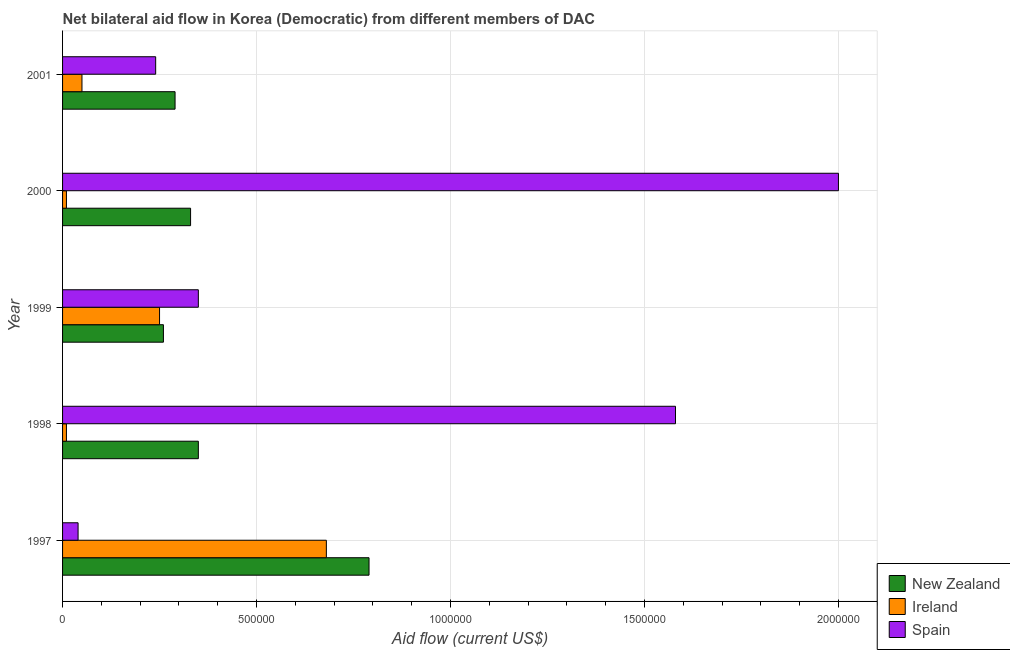How many different coloured bars are there?
Your answer should be very brief. 3. How many groups of bars are there?
Your answer should be compact. 5. Are the number of bars per tick equal to the number of legend labels?
Ensure brevity in your answer.  Yes. How many bars are there on the 1st tick from the top?
Your response must be concise. 3. What is the label of the 2nd group of bars from the top?
Offer a terse response. 2000. What is the amount of aid provided by ireland in 2001?
Keep it short and to the point. 5.00e+04. Across all years, what is the maximum amount of aid provided by spain?
Provide a succinct answer. 2.00e+06. Across all years, what is the minimum amount of aid provided by ireland?
Offer a very short reply. 10000. What is the total amount of aid provided by spain in the graph?
Your answer should be very brief. 4.21e+06. What is the difference between the amount of aid provided by spain in 1997 and that in 2001?
Make the answer very short. -2.00e+05. What is the difference between the amount of aid provided by ireland in 2001 and the amount of aid provided by spain in 1997?
Your answer should be very brief. 10000. What is the average amount of aid provided by spain per year?
Offer a terse response. 8.42e+05. In the year 2000, what is the difference between the amount of aid provided by new zealand and amount of aid provided by ireland?
Provide a short and direct response. 3.20e+05. What is the ratio of the amount of aid provided by new zealand in 1998 to that in 2001?
Make the answer very short. 1.21. What is the difference between the highest and the second highest amount of aid provided by ireland?
Give a very brief answer. 4.30e+05. What is the difference between the highest and the lowest amount of aid provided by spain?
Your response must be concise. 1.96e+06. What does the 2nd bar from the top in 2000 represents?
Provide a short and direct response. Ireland. What does the 1st bar from the bottom in 2000 represents?
Your answer should be very brief. New Zealand. How many bars are there?
Provide a succinct answer. 15. Are all the bars in the graph horizontal?
Offer a terse response. Yes. How many years are there in the graph?
Give a very brief answer. 5. Are the values on the major ticks of X-axis written in scientific E-notation?
Your response must be concise. No. Does the graph contain any zero values?
Your answer should be very brief. No. What is the title of the graph?
Ensure brevity in your answer.  Net bilateral aid flow in Korea (Democratic) from different members of DAC. Does "Ages 20-60" appear as one of the legend labels in the graph?
Give a very brief answer. No. What is the label or title of the Y-axis?
Ensure brevity in your answer.  Year. What is the Aid flow (current US$) of New Zealand in 1997?
Your response must be concise. 7.90e+05. What is the Aid flow (current US$) in Ireland in 1997?
Your answer should be compact. 6.80e+05. What is the Aid flow (current US$) of Spain in 1997?
Ensure brevity in your answer.  4.00e+04. What is the Aid flow (current US$) in New Zealand in 1998?
Keep it short and to the point. 3.50e+05. What is the Aid flow (current US$) in Spain in 1998?
Your response must be concise. 1.58e+06. What is the Aid flow (current US$) in Ireland in 1999?
Keep it short and to the point. 2.50e+05. What is the Aid flow (current US$) in Spain in 1999?
Your answer should be compact. 3.50e+05. What is the Aid flow (current US$) of New Zealand in 2000?
Give a very brief answer. 3.30e+05. What is the Aid flow (current US$) of Spain in 2000?
Your answer should be compact. 2.00e+06. What is the Aid flow (current US$) of New Zealand in 2001?
Provide a succinct answer. 2.90e+05. What is the Aid flow (current US$) of Spain in 2001?
Your answer should be compact. 2.40e+05. Across all years, what is the maximum Aid flow (current US$) of New Zealand?
Your response must be concise. 7.90e+05. Across all years, what is the maximum Aid flow (current US$) in Ireland?
Offer a terse response. 6.80e+05. Across all years, what is the maximum Aid flow (current US$) in Spain?
Provide a short and direct response. 2.00e+06. What is the total Aid flow (current US$) in New Zealand in the graph?
Provide a short and direct response. 2.02e+06. What is the total Aid flow (current US$) in Ireland in the graph?
Your answer should be compact. 1.00e+06. What is the total Aid flow (current US$) of Spain in the graph?
Your response must be concise. 4.21e+06. What is the difference between the Aid flow (current US$) in New Zealand in 1997 and that in 1998?
Your answer should be compact. 4.40e+05. What is the difference between the Aid flow (current US$) of Ireland in 1997 and that in 1998?
Keep it short and to the point. 6.70e+05. What is the difference between the Aid flow (current US$) in Spain in 1997 and that in 1998?
Offer a very short reply. -1.54e+06. What is the difference between the Aid flow (current US$) in New Zealand in 1997 and that in 1999?
Provide a short and direct response. 5.30e+05. What is the difference between the Aid flow (current US$) in Ireland in 1997 and that in 1999?
Keep it short and to the point. 4.30e+05. What is the difference between the Aid flow (current US$) in Spain in 1997 and that in 1999?
Your response must be concise. -3.10e+05. What is the difference between the Aid flow (current US$) of Ireland in 1997 and that in 2000?
Provide a short and direct response. 6.70e+05. What is the difference between the Aid flow (current US$) in Spain in 1997 and that in 2000?
Your response must be concise. -1.96e+06. What is the difference between the Aid flow (current US$) in New Zealand in 1997 and that in 2001?
Offer a very short reply. 5.00e+05. What is the difference between the Aid flow (current US$) of Ireland in 1997 and that in 2001?
Your answer should be very brief. 6.30e+05. What is the difference between the Aid flow (current US$) in Spain in 1997 and that in 2001?
Your answer should be very brief. -2.00e+05. What is the difference between the Aid flow (current US$) of New Zealand in 1998 and that in 1999?
Your answer should be compact. 9.00e+04. What is the difference between the Aid flow (current US$) in Ireland in 1998 and that in 1999?
Offer a terse response. -2.40e+05. What is the difference between the Aid flow (current US$) in Spain in 1998 and that in 1999?
Your answer should be very brief. 1.23e+06. What is the difference between the Aid flow (current US$) in New Zealand in 1998 and that in 2000?
Your response must be concise. 2.00e+04. What is the difference between the Aid flow (current US$) of Ireland in 1998 and that in 2000?
Your answer should be compact. 0. What is the difference between the Aid flow (current US$) in Spain in 1998 and that in 2000?
Ensure brevity in your answer.  -4.20e+05. What is the difference between the Aid flow (current US$) of Ireland in 1998 and that in 2001?
Your answer should be very brief. -4.00e+04. What is the difference between the Aid flow (current US$) of Spain in 1998 and that in 2001?
Offer a very short reply. 1.34e+06. What is the difference between the Aid flow (current US$) of New Zealand in 1999 and that in 2000?
Keep it short and to the point. -7.00e+04. What is the difference between the Aid flow (current US$) in Ireland in 1999 and that in 2000?
Provide a short and direct response. 2.40e+05. What is the difference between the Aid flow (current US$) in Spain in 1999 and that in 2000?
Your answer should be very brief. -1.65e+06. What is the difference between the Aid flow (current US$) of New Zealand in 1999 and that in 2001?
Give a very brief answer. -3.00e+04. What is the difference between the Aid flow (current US$) in Ireland in 1999 and that in 2001?
Ensure brevity in your answer.  2.00e+05. What is the difference between the Aid flow (current US$) in Spain in 2000 and that in 2001?
Provide a succinct answer. 1.76e+06. What is the difference between the Aid flow (current US$) of New Zealand in 1997 and the Aid flow (current US$) of Ireland in 1998?
Make the answer very short. 7.80e+05. What is the difference between the Aid flow (current US$) in New Zealand in 1997 and the Aid flow (current US$) in Spain in 1998?
Your response must be concise. -7.90e+05. What is the difference between the Aid flow (current US$) in Ireland in 1997 and the Aid flow (current US$) in Spain in 1998?
Make the answer very short. -9.00e+05. What is the difference between the Aid flow (current US$) in New Zealand in 1997 and the Aid flow (current US$) in Ireland in 1999?
Your answer should be very brief. 5.40e+05. What is the difference between the Aid flow (current US$) in New Zealand in 1997 and the Aid flow (current US$) in Spain in 1999?
Offer a terse response. 4.40e+05. What is the difference between the Aid flow (current US$) in New Zealand in 1997 and the Aid flow (current US$) in Ireland in 2000?
Your answer should be compact. 7.80e+05. What is the difference between the Aid flow (current US$) of New Zealand in 1997 and the Aid flow (current US$) of Spain in 2000?
Provide a short and direct response. -1.21e+06. What is the difference between the Aid flow (current US$) of Ireland in 1997 and the Aid flow (current US$) of Spain in 2000?
Your answer should be compact. -1.32e+06. What is the difference between the Aid flow (current US$) of New Zealand in 1997 and the Aid flow (current US$) of Ireland in 2001?
Your response must be concise. 7.40e+05. What is the difference between the Aid flow (current US$) in New Zealand in 1997 and the Aid flow (current US$) in Spain in 2001?
Your answer should be very brief. 5.50e+05. What is the difference between the Aid flow (current US$) of New Zealand in 1998 and the Aid flow (current US$) of Ireland in 2000?
Give a very brief answer. 3.40e+05. What is the difference between the Aid flow (current US$) of New Zealand in 1998 and the Aid flow (current US$) of Spain in 2000?
Give a very brief answer. -1.65e+06. What is the difference between the Aid flow (current US$) in Ireland in 1998 and the Aid flow (current US$) in Spain in 2000?
Provide a succinct answer. -1.99e+06. What is the difference between the Aid flow (current US$) of Ireland in 1998 and the Aid flow (current US$) of Spain in 2001?
Your response must be concise. -2.30e+05. What is the difference between the Aid flow (current US$) of New Zealand in 1999 and the Aid flow (current US$) of Ireland in 2000?
Ensure brevity in your answer.  2.50e+05. What is the difference between the Aid flow (current US$) in New Zealand in 1999 and the Aid flow (current US$) in Spain in 2000?
Offer a terse response. -1.74e+06. What is the difference between the Aid flow (current US$) in Ireland in 1999 and the Aid flow (current US$) in Spain in 2000?
Provide a short and direct response. -1.75e+06. What is the difference between the Aid flow (current US$) in New Zealand in 1999 and the Aid flow (current US$) in Ireland in 2001?
Your answer should be compact. 2.10e+05. What is the difference between the Aid flow (current US$) in New Zealand in 2000 and the Aid flow (current US$) in Ireland in 2001?
Ensure brevity in your answer.  2.80e+05. What is the difference between the Aid flow (current US$) in New Zealand in 2000 and the Aid flow (current US$) in Spain in 2001?
Provide a succinct answer. 9.00e+04. What is the average Aid flow (current US$) in New Zealand per year?
Give a very brief answer. 4.04e+05. What is the average Aid flow (current US$) of Spain per year?
Provide a short and direct response. 8.42e+05. In the year 1997, what is the difference between the Aid flow (current US$) of New Zealand and Aid flow (current US$) of Ireland?
Provide a succinct answer. 1.10e+05. In the year 1997, what is the difference between the Aid flow (current US$) in New Zealand and Aid flow (current US$) in Spain?
Your answer should be very brief. 7.50e+05. In the year 1997, what is the difference between the Aid flow (current US$) in Ireland and Aid flow (current US$) in Spain?
Your answer should be compact. 6.40e+05. In the year 1998, what is the difference between the Aid flow (current US$) of New Zealand and Aid flow (current US$) of Spain?
Provide a succinct answer. -1.23e+06. In the year 1998, what is the difference between the Aid flow (current US$) in Ireland and Aid flow (current US$) in Spain?
Provide a short and direct response. -1.57e+06. In the year 1999, what is the difference between the Aid flow (current US$) of New Zealand and Aid flow (current US$) of Spain?
Provide a succinct answer. -9.00e+04. In the year 2000, what is the difference between the Aid flow (current US$) in New Zealand and Aid flow (current US$) in Spain?
Give a very brief answer. -1.67e+06. In the year 2000, what is the difference between the Aid flow (current US$) of Ireland and Aid flow (current US$) of Spain?
Offer a terse response. -1.99e+06. In the year 2001, what is the difference between the Aid flow (current US$) of New Zealand and Aid flow (current US$) of Ireland?
Provide a short and direct response. 2.40e+05. In the year 2001, what is the difference between the Aid flow (current US$) in Ireland and Aid flow (current US$) in Spain?
Offer a very short reply. -1.90e+05. What is the ratio of the Aid flow (current US$) of New Zealand in 1997 to that in 1998?
Give a very brief answer. 2.26. What is the ratio of the Aid flow (current US$) of Ireland in 1997 to that in 1998?
Your response must be concise. 68. What is the ratio of the Aid flow (current US$) in Spain in 1997 to that in 1998?
Ensure brevity in your answer.  0.03. What is the ratio of the Aid flow (current US$) in New Zealand in 1997 to that in 1999?
Give a very brief answer. 3.04. What is the ratio of the Aid flow (current US$) in Ireland in 1997 to that in 1999?
Make the answer very short. 2.72. What is the ratio of the Aid flow (current US$) of Spain in 1997 to that in 1999?
Ensure brevity in your answer.  0.11. What is the ratio of the Aid flow (current US$) in New Zealand in 1997 to that in 2000?
Offer a very short reply. 2.39. What is the ratio of the Aid flow (current US$) of Ireland in 1997 to that in 2000?
Your response must be concise. 68. What is the ratio of the Aid flow (current US$) in Spain in 1997 to that in 2000?
Your answer should be very brief. 0.02. What is the ratio of the Aid flow (current US$) of New Zealand in 1997 to that in 2001?
Your response must be concise. 2.72. What is the ratio of the Aid flow (current US$) in Spain in 1997 to that in 2001?
Your answer should be compact. 0.17. What is the ratio of the Aid flow (current US$) of New Zealand in 1998 to that in 1999?
Make the answer very short. 1.35. What is the ratio of the Aid flow (current US$) in Ireland in 1998 to that in 1999?
Ensure brevity in your answer.  0.04. What is the ratio of the Aid flow (current US$) of Spain in 1998 to that in 1999?
Provide a short and direct response. 4.51. What is the ratio of the Aid flow (current US$) in New Zealand in 1998 to that in 2000?
Keep it short and to the point. 1.06. What is the ratio of the Aid flow (current US$) in Ireland in 1998 to that in 2000?
Your answer should be very brief. 1. What is the ratio of the Aid flow (current US$) of Spain in 1998 to that in 2000?
Ensure brevity in your answer.  0.79. What is the ratio of the Aid flow (current US$) in New Zealand in 1998 to that in 2001?
Make the answer very short. 1.21. What is the ratio of the Aid flow (current US$) of Ireland in 1998 to that in 2001?
Provide a short and direct response. 0.2. What is the ratio of the Aid flow (current US$) in Spain in 1998 to that in 2001?
Offer a terse response. 6.58. What is the ratio of the Aid flow (current US$) in New Zealand in 1999 to that in 2000?
Offer a very short reply. 0.79. What is the ratio of the Aid flow (current US$) of Spain in 1999 to that in 2000?
Offer a terse response. 0.17. What is the ratio of the Aid flow (current US$) of New Zealand in 1999 to that in 2001?
Your answer should be very brief. 0.9. What is the ratio of the Aid flow (current US$) in Ireland in 1999 to that in 2001?
Keep it short and to the point. 5. What is the ratio of the Aid flow (current US$) of Spain in 1999 to that in 2001?
Offer a very short reply. 1.46. What is the ratio of the Aid flow (current US$) in New Zealand in 2000 to that in 2001?
Provide a short and direct response. 1.14. What is the ratio of the Aid flow (current US$) in Ireland in 2000 to that in 2001?
Provide a short and direct response. 0.2. What is the ratio of the Aid flow (current US$) of Spain in 2000 to that in 2001?
Your answer should be very brief. 8.33. What is the difference between the highest and the second highest Aid flow (current US$) of Ireland?
Offer a very short reply. 4.30e+05. What is the difference between the highest and the second highest Aid flow (current US$) of Spain?
Offer a very short reply. 4.20e+05. What is the difference between the highest and the lowest Aid flow (current US$) in New Zealand?
Provide a short and direct response. 5.30e+05. What is the difference between the highest and the lowest Aid flow (current US$) of Ireland?
Your response must be concise. 6.70e+05. What is the difference between the highest and the lowest Aid flow (current US$) of Spain?
Give a very brief answer. 1.96e+06. 